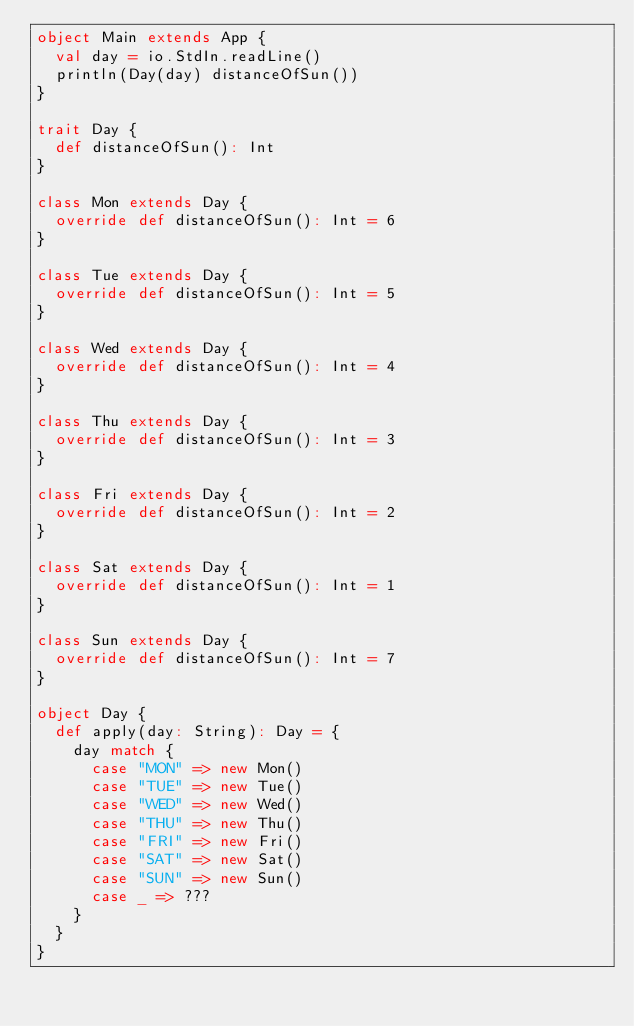<code> <loc_0><loc_0><loc_500><loc_500><_Scala_>object Main extends App {
  val day = io.StdIn.readLine()
  println(Day(day) distanceOfSun())
}

trait Day {
  def distanceOfSun(): Int
}

class Mon extends Day {
  override def distanceOfSun(): Int = 6
}

class Tue extends Day {
  override def distanceOfSun(): Int = 5
}

class Wed extends Day {
  override def distanceOfSun(): Int = 4
}

class Thu extends Day {
  override def distanceOfSun(): Int = 3
}

class Fri extends Day {
  override def distanceOfSun(): Int = 2
}

class Sat extends Day {
  override def distanceOfSun(): Int = 1
}

class Sun extends Day {
  override def distanceOfSun(): Int = 7
}

object Day {
  def apply(day: String): Day = {
    day match {
      case "MON" => new Mon()
      case "TUE" => new Tue()
      case "WED" => new Wed()
      case "THU" => new Thu()
      case "FRI" => new Fri()
      case "SAT" => new Sat()
      case "SUN" => new Sun()
      case _ => ???
    }
  }
}
</code> 